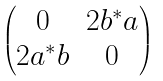Convert formula to latex. <formula><loc_0><loc_0><loc_500><loc_500>\begin{pmatrix} 0 & 2 b ^ { * } a \\ 2 a ^ { * } b & 0 \end{pmatrix}</formula> 